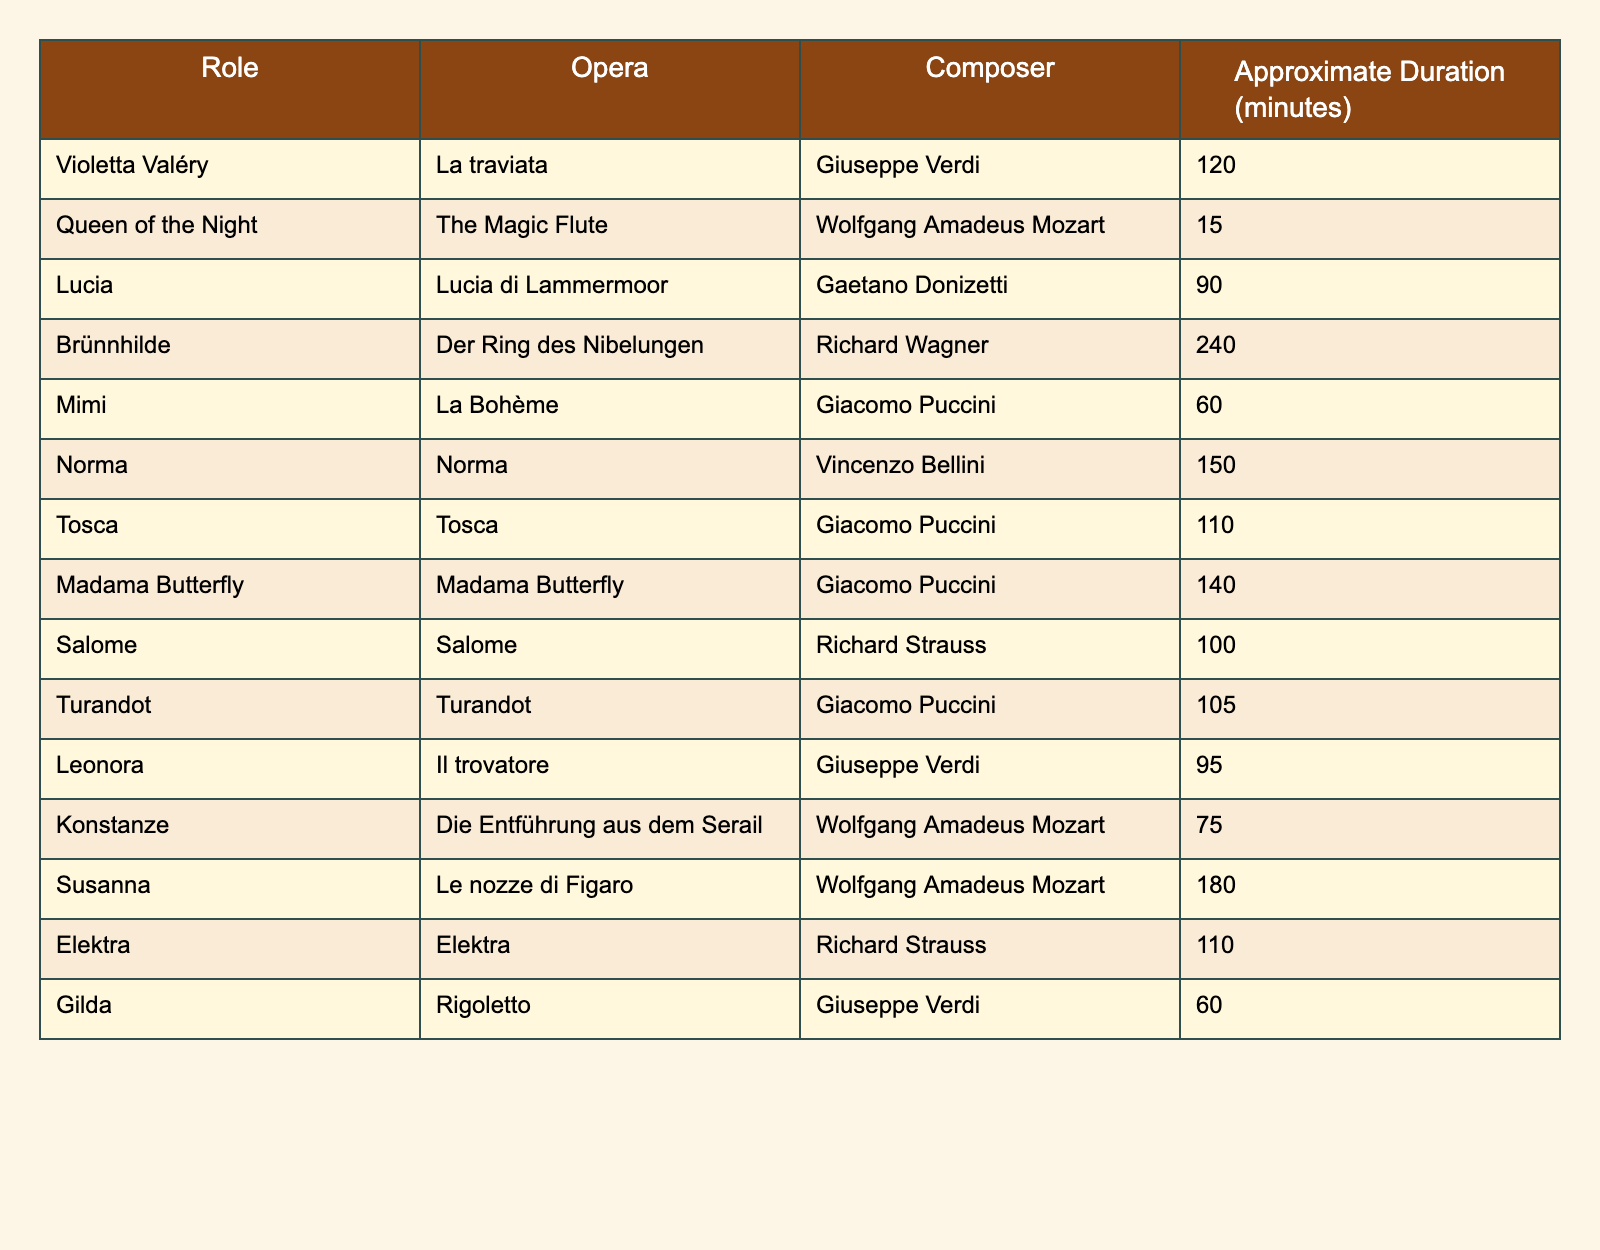What is the duration of the role Violetta Valéry? According to the table, the approximate duration of the role Violetta Valéry in the opera La traviata is 120 minutes.
Answer: 120 minutes Which role has the shortest performance duration? The role with the shortest performance duration is Queen of the Night, which lasts 15 minutes according to the table.
Answer: Queen of the Night How many minutes does the role Brünnhilde require? The table states that the role of Brünnhilde from Der Ring des Nibelungen has an approximate duration of 240 minutes.
Answer: 240 minutes What is the total duration of the roles from Puccini's operas? The roles from Puccini listed are Mimi (60), Tosca (110), Madama Butterfly (140), and Turandot (105). Summing these gives 60 + 110 + 140 + 105 = 415 minutes.
Answer: 415 minutes How many roles listed last longer than 100 minutes? The roles that last longer than 100 minutes are Violetta Valéry (120), Brünnhilde (240), Norma (150), Madama Butterfly (140), Susanna (180), and Elektra (110). Counting these gives 6 roles.
Answer: 6 roles Is there a role by Mozart that has a duration longer than 75 minutes? Yes, Konstanze from Die Entführung aus dem Serail lasts 75 minutes, which indicates that no roles by Mozart last longer. Thus, the answer is no.
Answer: No What is the average duration of the roles by Verdi? The roles by Verdi in the table are Violetta Valéry (120), Leonora (95), and Gilda (60). First, add the durations: 120 + 95 + 60 = 275. There are 3 roles, so the average is 275 divided by 3, which equals approximately 91.67 minutes.
Answer: Approximately 91.67 minutes Which role has a duration closest to 100 minutes? The roles with durations closest to 100 minutes are Salome (100) and Turandot (105). Salome is directly 100 minutes. Thus, the closest is Salome.
Answer: Salome How does the duration of Tosca compare to that of Lucia? Tosca lasts 110 minutes and Lucia lasts 90 minutes. Therefore, Tosca is longer than Lucia by 20 minutes (110 - 90).
Answer: Tosca is 20 minutes longer What percentage of the roles last over 150 minutes? There are 15 total roles in the table, and only Brünnhilde lasts over 150 minutes. To find the percentage: (1/15) * 100 = 6.67%.
Answer: 6.67% 